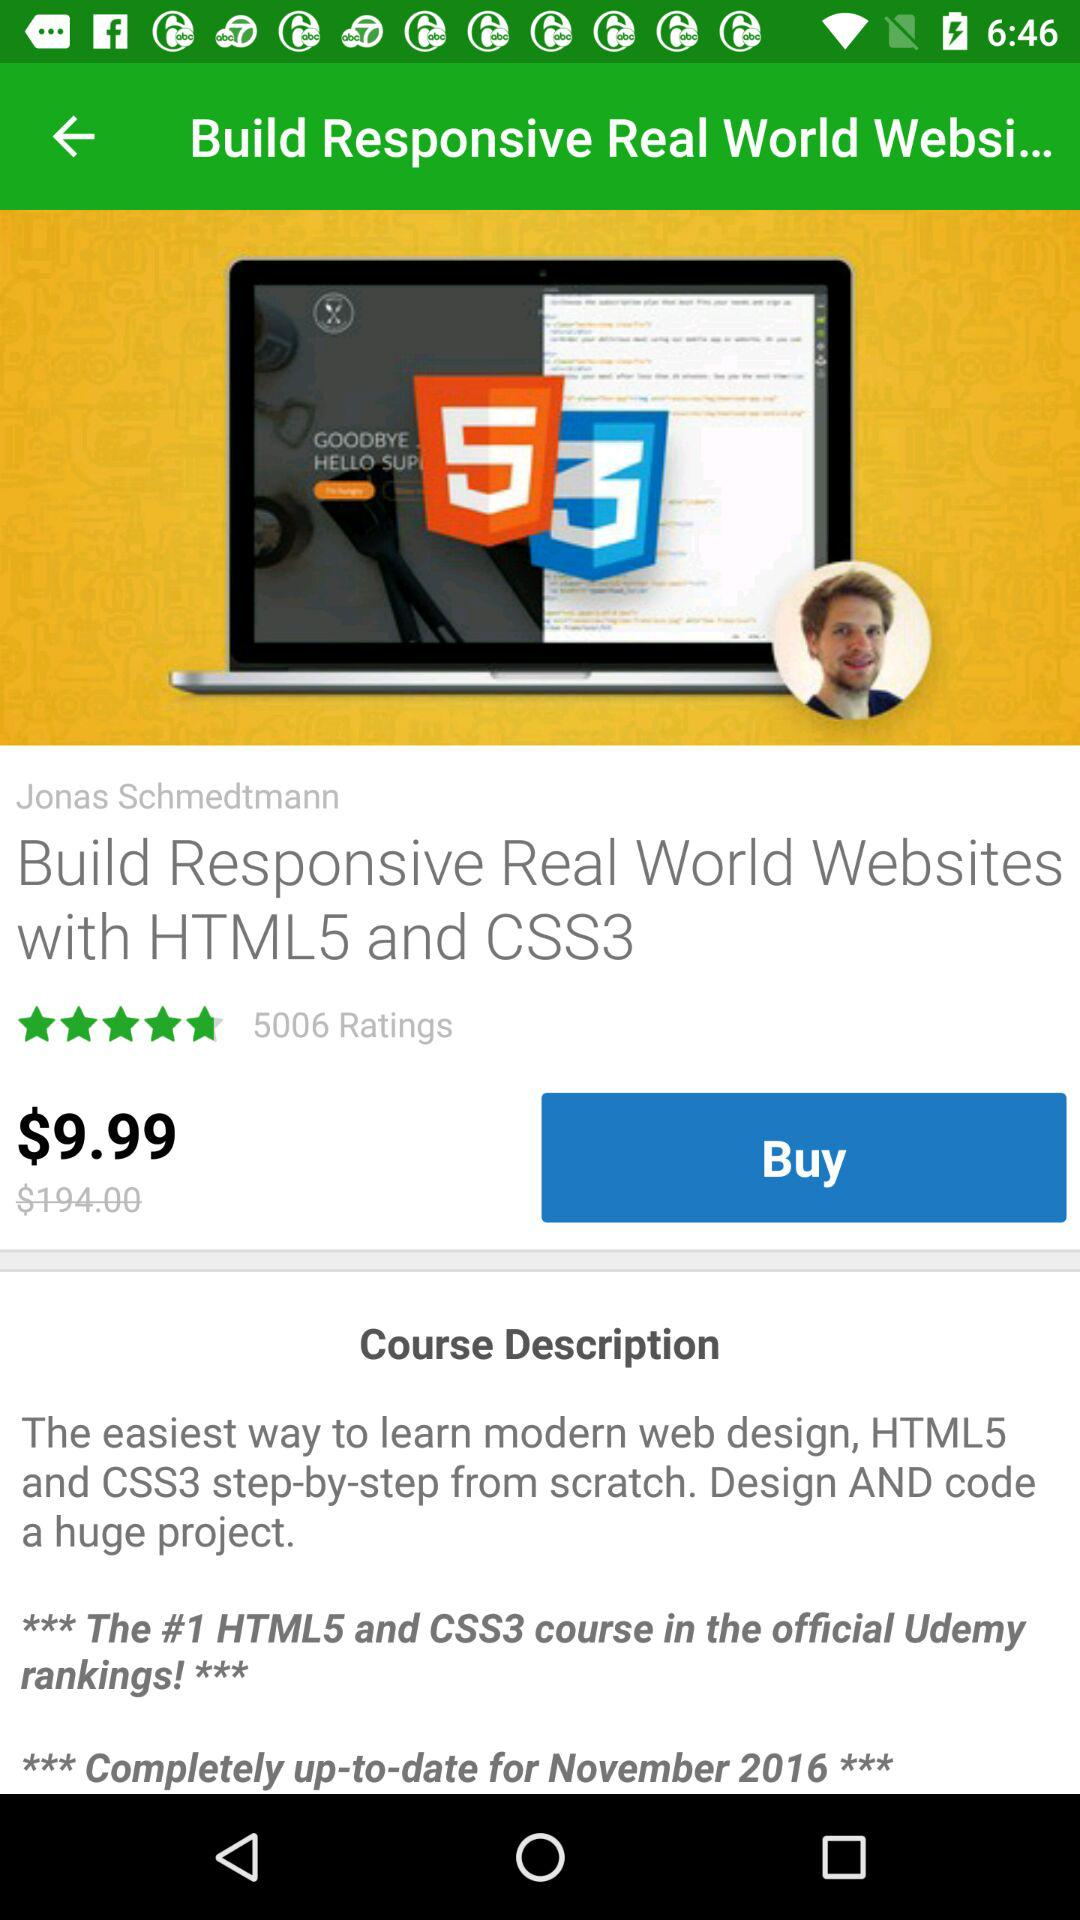What's the price of the course? The price of the course is $9.99. 